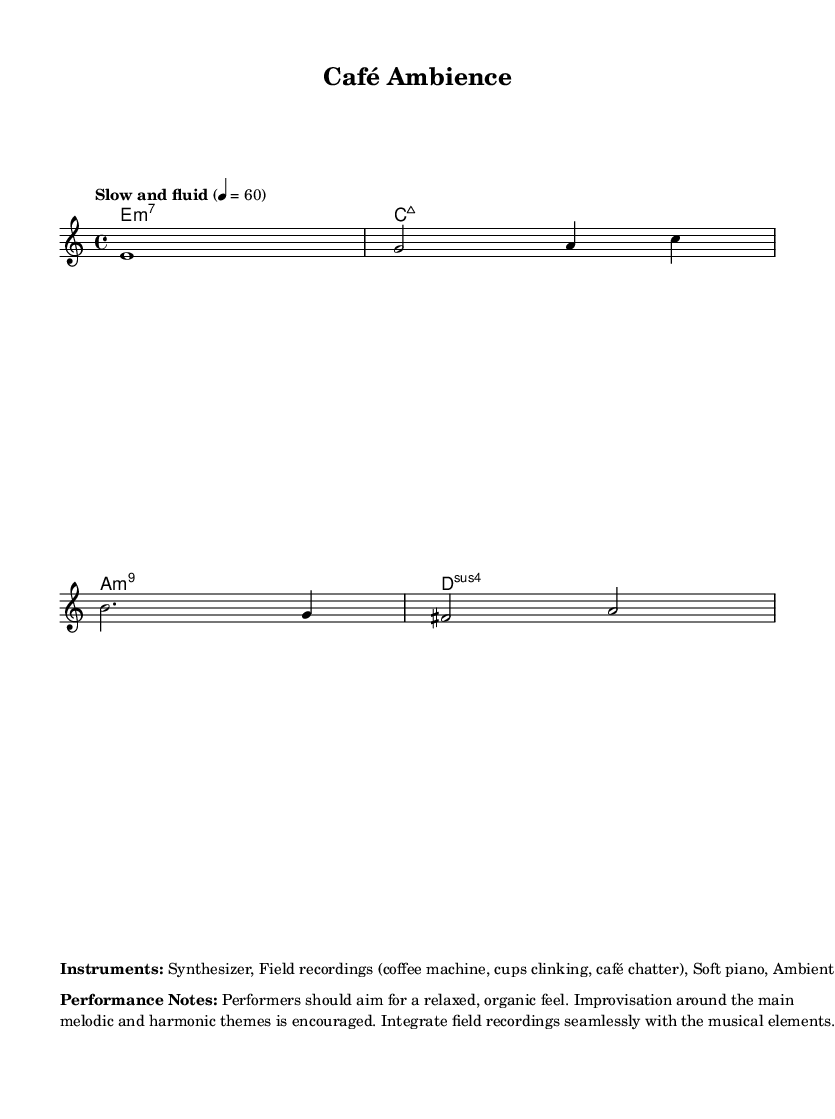What is the time signature of this music? The time signature is represented at the beginning of the music and is marked as "4/4," indicating that there are four beats in each measure.
Answer: 4/4 What is the tempo marking for this piece? The tempo is indicated in the music score as "Slow and fluid" with a metronome marking of 60 beats per minute. This suggests a relaxed pace for the performance.
Answer: Slow and fluid What type of chords are indicated in the harmonies? The chord progression includes an E minor 7 (e1:m7), C major 7 (c1:maj7), A minor 9 (a1:m9), and D suspended 4 (d1:sus4), which are characteristic of ambient and experimental music.
Answer: Minor and Major 7th chords How many measures are in the melody line? By counting the number of bar lines that separate the sections within the melody, we determine the total number of measures. There are five bars total in the melody line.
Answer: Five measures What instruments are suggested for this composition? The markup at the bottom of the score explicitly lists the suggested instruments, which include Synthesizer, field recordings, Soft piano, and Ambient pads, indicating a focus on atmospheric sounds.
Answer: Synthesizer, Field recordings, Soft piano, Ambient pads What performance style is encouraged for the musicians? The performance notes suggest that musicians should aim for a relaxed, organic feel and encourages improvisation, which is important for creating ambient soundscapes.
Answer: Relaxed, organic feel 